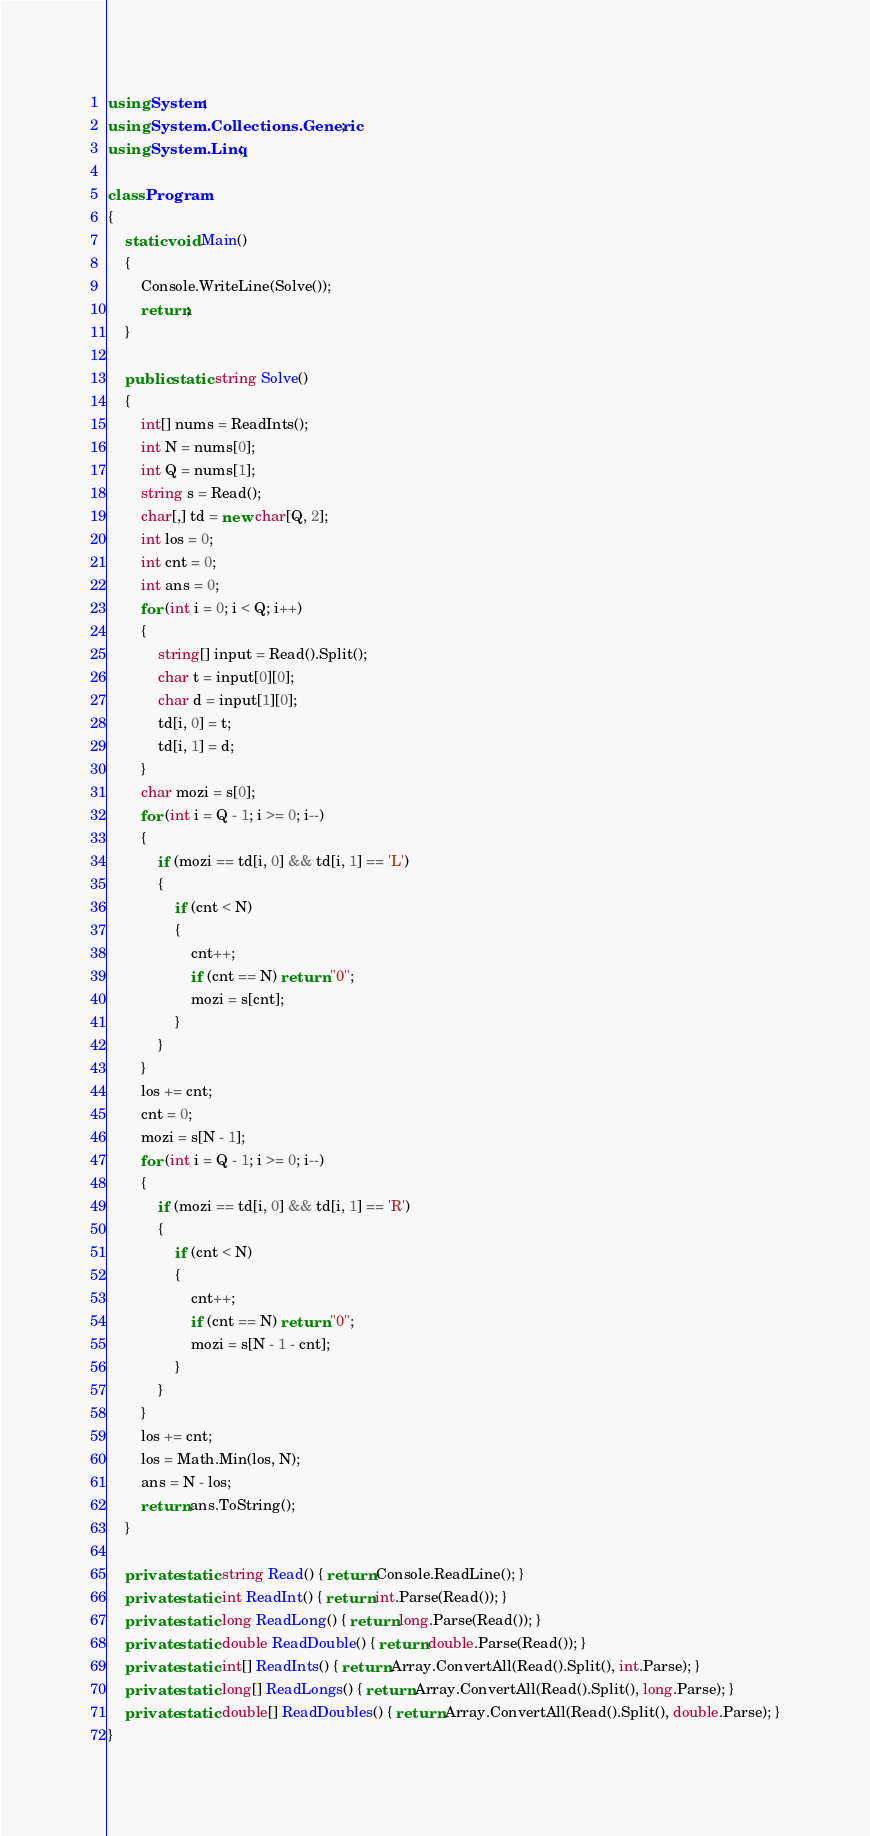<code> <loc_0><loc_0><loc_500><loc_500><_C#_>using System;
using System.Collections.Generic;
using System.Linq;

class Program
{
    static void Main()
    {
        Console.WriteLine(Solve());
        return;
    }

    public static string Solve()
    {
        int[] nums = ReadInts();
        int N = nums[0];
        int Q = nums[1];
        string s = Read();
        char[,] td = new char[Q, 2];
        int los = 0;
        int cnt = 0;
        int ans = 0;
        for (int i = 0; i < Q; i++)
        {
            string[] input = Read().Split();
            char t = input[0][0];
            char d = input[1][0];
            td[i, 0] = t;
            td[i, 1] = d;
        }
        char mozi = s[0];
        for (int i = Q - 1; i >= 0; i--)
        {
            if (mozi == td[i, 0] && td[i, 1] == 'L')
            {
                if (cnt < N)
                {
                    cnt++;
                    if (cnt == N) return "0";
                    mozi = s[cnt];
                }
            }
        }
        los += cnt;
        cnt = 0;
        mozi = s[N - 1];
        for (int i = Q - 1; i >= 0; i--)
        {
            if (mozi == td[i, 0] && td[i, 1] == 'R')
            {
                if (cnt < N)
                {
                    cnt++;
                    if (cnt == N) return "0";
                    mozi = s[N - 1 - cnt];
                }
            }
        }
        los += cnt;
        los = Math.Min(los, N);
        ans = N - los;
        return ans.ToString();
    }

    private static string Read() { return Console.ReadLine(); }
    private static int ReadInt() { return int.Parse(Read()); }
    private static long ReadLong() { return long.Parse(Read()); }
    private static double ReadDouble() { return double.Parse(Read()); }
    private static int[] ReadInts() { return Array.ConvertAll(Read().Split(), int.Parse); }
    private static long[] ReadLongs() { return Array.ConvertAll(Read().Split(), long.Parse); }
    private static double[] ReadDoubles() { return Array.ConvertAll(Read().Split(), double.Parse); }
}
</code> 